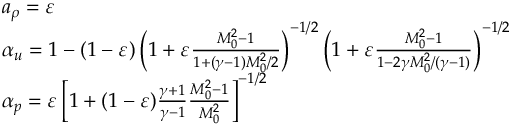Convert formula to latex. <formula><loc_0><loc_0><loc_500><loc_500>\begin{array} { r l } & { a _ { \rho } = \varepsilon } \\ & { \alpha _ { u } = 1 - ( 1 - \varepsilon ) \left ( 1 + \varepsilon \frac { M _ { 0 } ^ { 2 } - 1 } { 1 + ( \gamma - 1 ) M _ { 0 } ^ { 2 } / 2 } \right ) ^ { - 1 / 2 } \left ( 1 + \varepsilon \frac { M _ { 0 } ^ { 2 } - 1 } { 1 - 2 \gamma M _ { 0 } ^ { 2 } / ( \gamma - 1 ) } \right ) ^ { - 1 / 2 } } \\ & { \alpha _ { p } = \varepsilon \left [ 1 + ( 1 - \varepsilon ) \frac { \gamma + 1 } { \gamma - 1 } \frac { M _ { 0 } ^ { 2 } - 1 } { M _ { 0 } ^ { 2 } } \right ] ^ { - 1 / 2 } } \end{array}</formula> 